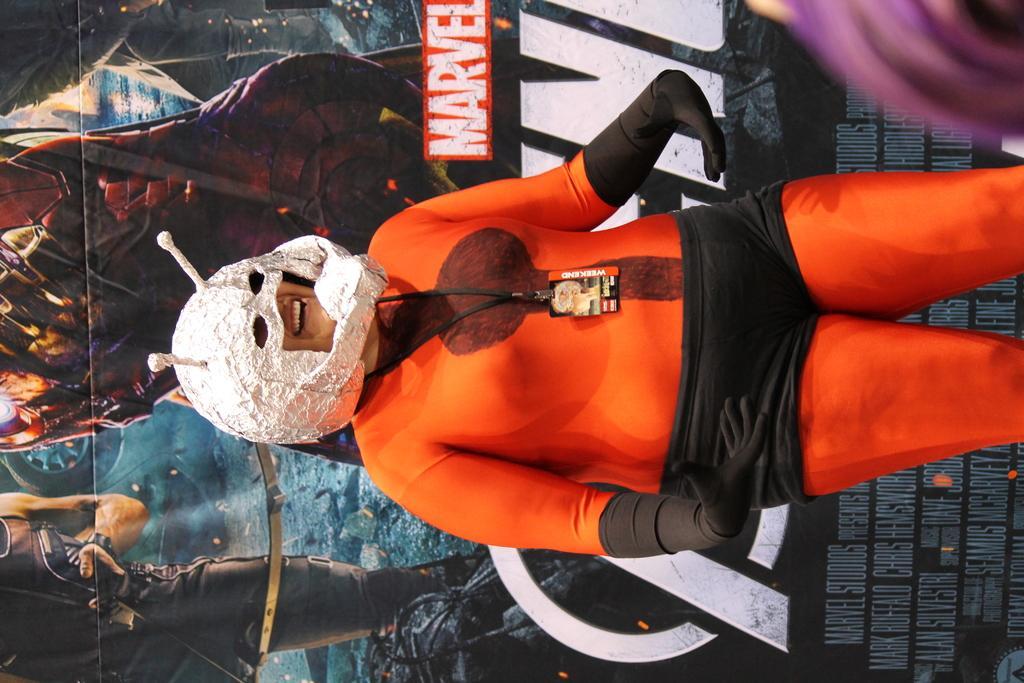Could you give a brief overview of what you see in this image? In this image I can see a woman wore different dress and she is smiling, this dress is in orange color. Behind her there is the banner of a movie. 